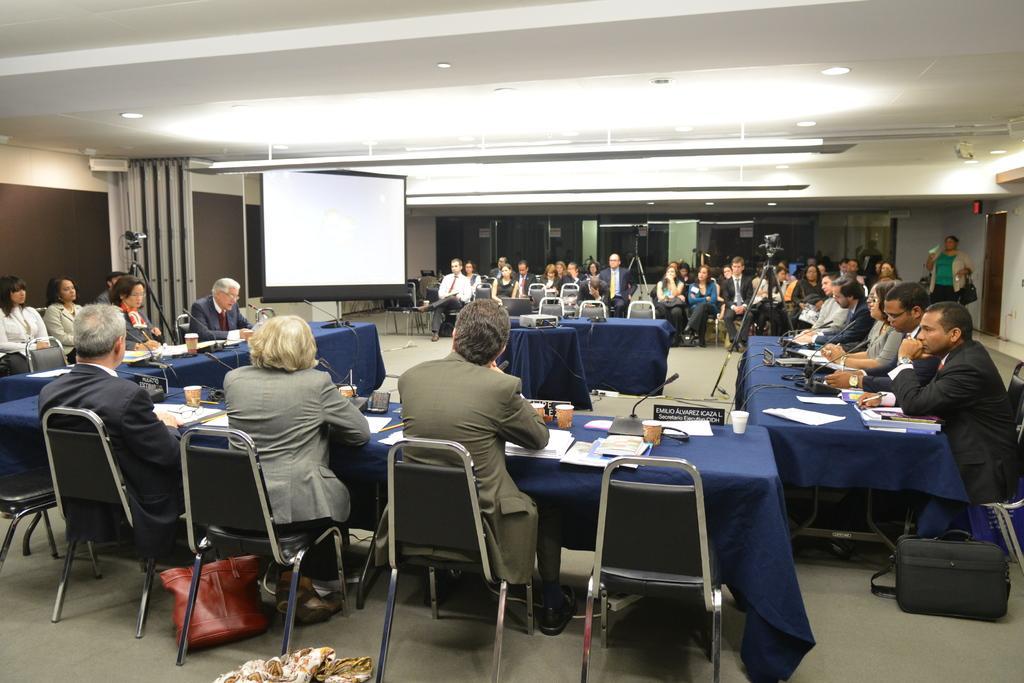What is happening in the room in the image? There are people in a room, and they are sitting on chairs. What are the people doing while sitting on the chairs? The people are talking on microphones. What else can be seen in the room besides the people and chairs? There are tables in the room. How many legs can be seen on the verse in the image? There is no verse present in the image, and therefore no legs can be counted. 